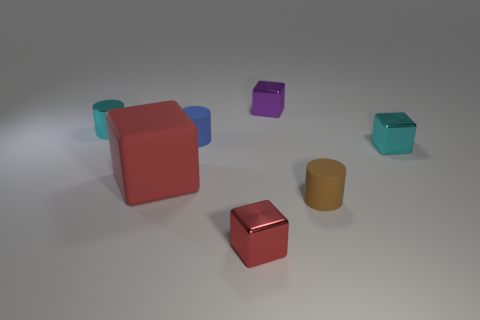Add 2 brown cylinders. How many objects exist? 9 Subtract all yellow cubes. Subtract all blue cylinders. How many cubes are left? 4 Subtract all cylinders. How many objects are left? 4 Add 1 tiny cyan shiny cylinders. How many tiny cyan shiny cylinders exist? 2 Subtract 0 purple cylinders. How many objects are left? 7 Subtract all red blocks. Subtract all small red shiny objects. How many objects are left? 4 Add 4 metal cylinders. How many metal cylinders are left? 5 